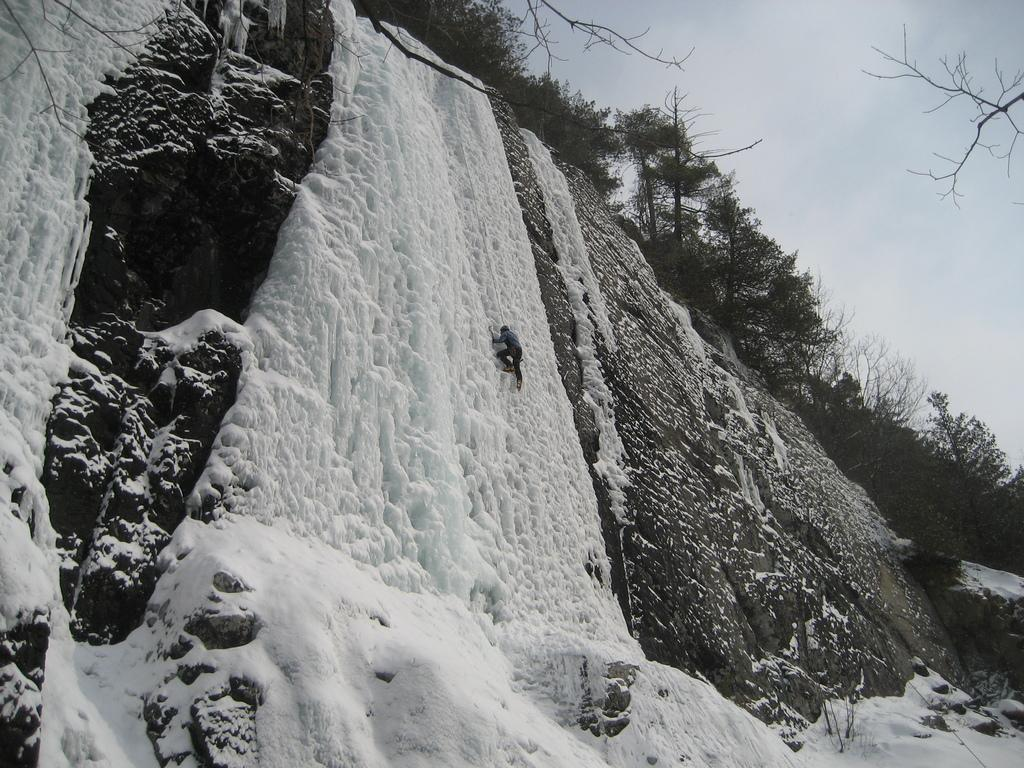What is the main subject in the foreground of the image? There is a person in the foreground of the image. What is the person doing in the image? The person is climbing on a cliff. What is the condition of the cliff? The cliff has snow on it. What can be seen in the background of the image? There are trees and the sky visible in the background of the image. What type of glass is being used by the person to engage in a battle in the image? There is no glass or battle present in the image; it features a person climbing on a snowy cliff. 